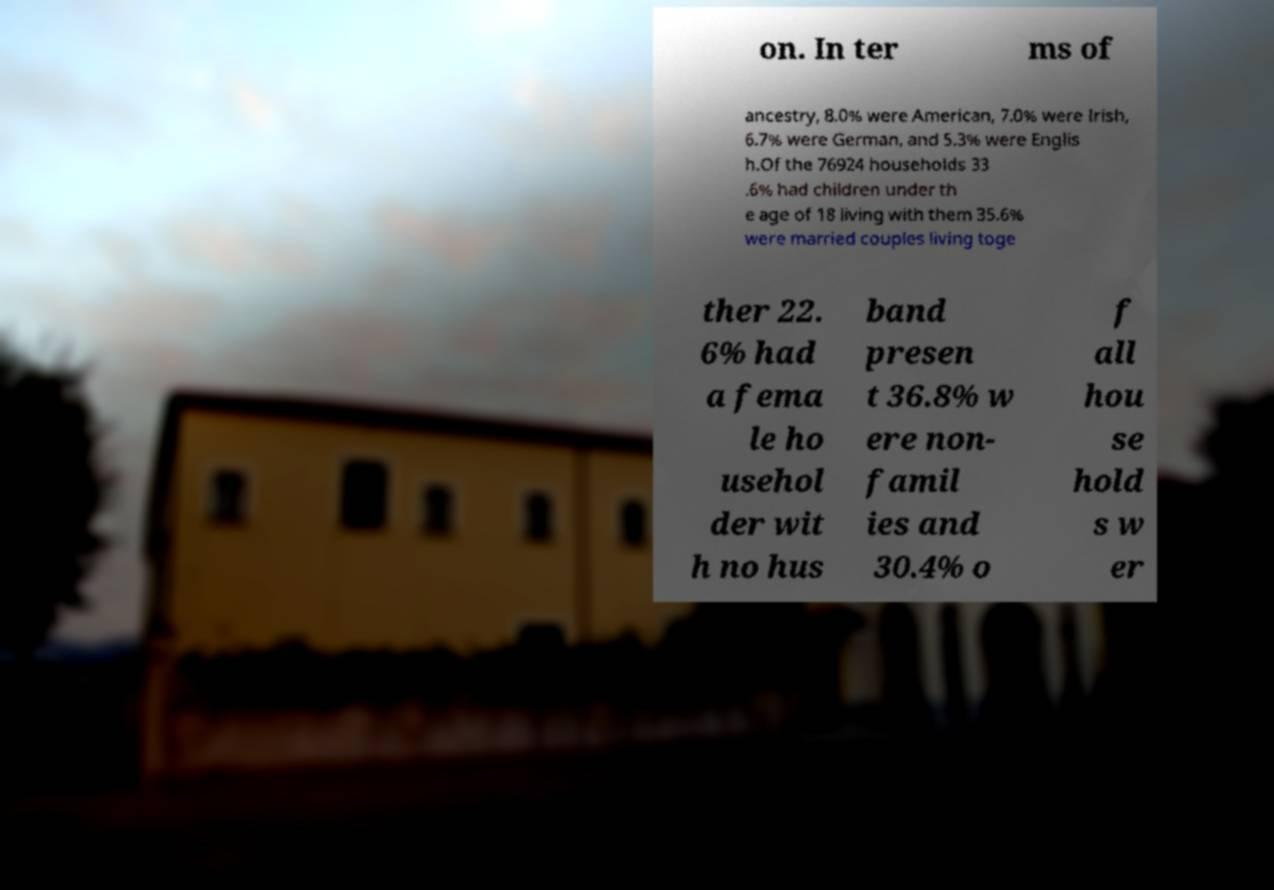There's text embedded in this image that I need extracted. Can you transcribe it verbatim? on. In ter ms of ancestry, 8.0% were American, 7.0% were Irish, 6.7% were German, and 5.3% were Englis h.Of the 76924 households 33 .6% had children under th e age of 18 living with them 35.6% were married couples living toge ther 22. 6% had a fema le ho usehol der wit h no hus band presen t 36.8% w ere non- famil ies and 30.4% o f all hou se hold s w er 